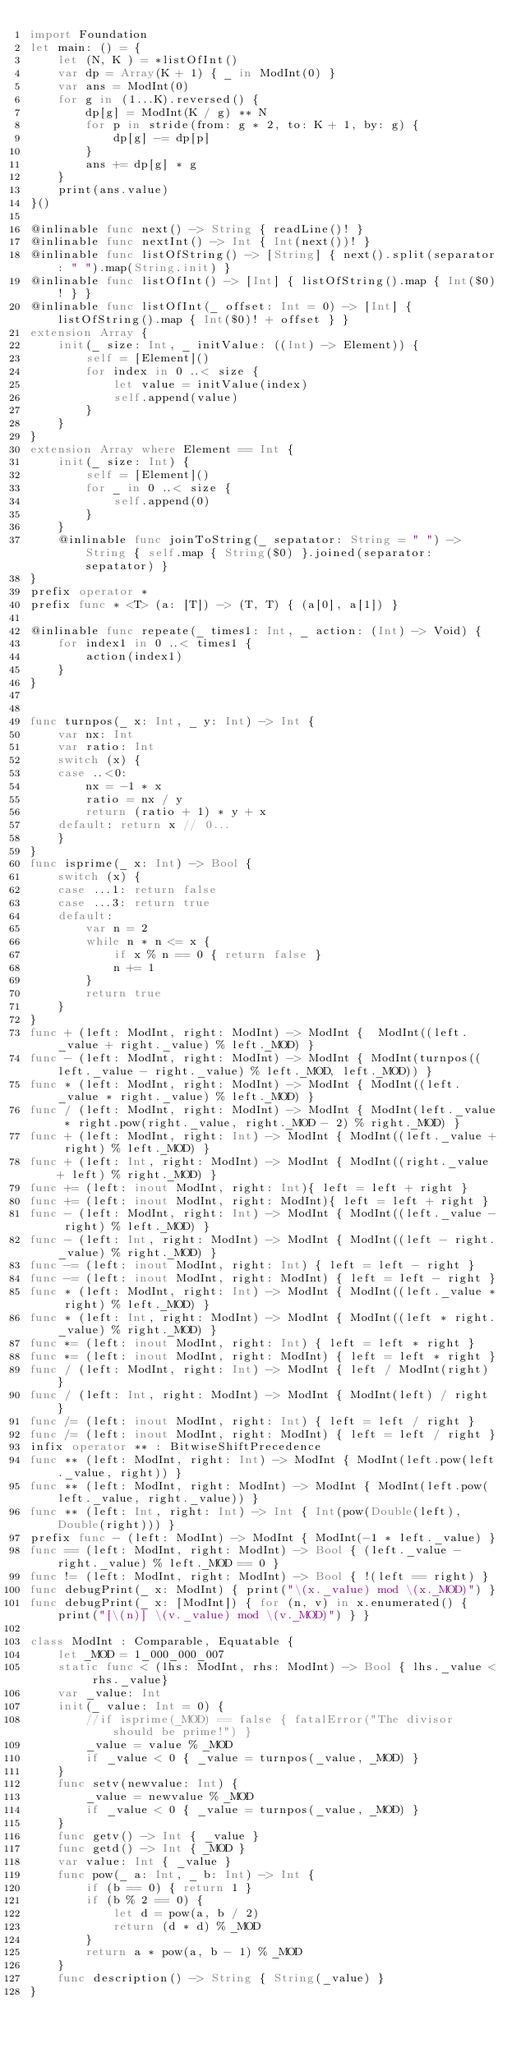Convert code to text. <code><loc_0><loc_0><loc_500><loc_500><_Swift_>import Foundation
let main: () = {
    let (N, K ) = *listOfInt()
    var dp = Array(K + 1) { _ in ModInt(0) }
    var ans = ModInt(0)
    for g in (1...K).reversed() {
        dp[g] = ModInt(K / g) ** N
        for p in stride(from: g * 2, to: K + 1, by: g) {
            dp[g] -= dp[p]
        }
        ans += dp[g] * g
    }
    print(ans.value)
}()

@inlinable func next() -> String { readLine()! }
@inlinable func nextInt() -> Int { Int(next())! }
@inlinable func listOfString() -> [String] { next().split(separator: " ").map(String.init) }
@inlinable func listOfInt() -> [Int] { listOfString().map { Int($0)! } }
@inlinable func listOfInt(_ offset: Int = 0) -> [Int] { listOfString().map { Int($0)! + offset } }
extension Array {
    init(_ size: Int, _ initValue: ((Int) -> Element)) {
        self = [Element]()
        for index in 0 ..< size {
            let value = initValue(index)
            self.append(value)
        }
    }
}
extension Array where Element == Int {
    init(_ size: Int) {
        self = [Element]()
        for _ in 0 ..< size {
            self.append(0)
        }
    }
    @inlinable func joinToString(_ sepatator: String = " ") -> String { self.map { String($0) }.joined(separator: sepatator) }
}
prefix operator *
prefix func * <T> (a: [T]) -> (T, T) { (a[0], a[1]) }

@inlinable func repeate(_ times1: Int, _ action: (Int) -> Void) {
    for index1 in 0 ..< times1 {
        action(index1)
    }
}


func turnpos(_ x: Int, _ y: Int) -> Int {
    var nx: Int
    var ratio: Int
    switch (x) {
    case ..<0:
        nx = -1 * x
        ratio = nx / y
        return (ratio + 1) * y + x
    default: return x // 0...
    }
}
func isprime(_ x: Int) -> Bool {
    switch (x) {
    case ...1: return false
    case ...3: return true
    default:
        var n = 2
        while n * n <= x {
            if x % n == 0 { return false }
            n += 1
        }
        return true
    }
}
func + (left: ModInt, right: ModInt) -> ModInt {  ModInt((left._value + right._value) % left._MOD) }
func - (left: ModInt, right: ModInt) -> ModInt { ModInt(turnpos((left._value - right._value) % left._MOD, left._MOD)) }
func * (left: ModInt, right: ModInt) -> ModInt { ModInt((left._value * right._value) % left._MOD) }
func / (left: ModInt, right: ModInt) -> ModInt { ModInt(left._value * right.pow(right._value, right._MOD - 2) % right._MOD) }
func + (left: ModInt, right: Int) -> ModInt { ModInt((left._value + right) % left._MOD) }
func + (left: Int, right: ModInt) -> ModInt { ModInt((right._value + left) % right._MOD) }
func += (left: inout ModInt, right: Int){ left = left + right }
func += (left: inout ModInt, right: ModInt){ left = left + right }
func - (left: ModInt, right: Int) -> ModInt { ModInt((left._value - right) % left._MOD) }
func - (left: Int, right: ModInt) -> ModInt { ModInt((left - right._value) % right._MOD) }
func -= (left: inout ModInt, right: Int) { left = left - right }
func -= (left: inout ModInt, right: ModInt) { left = left - right }
func * (left: ModInt, right: Int) -> ModInt { ModInt((left._value * right) % left._MOD) }
func * (left: Int, right: ModInt) -> ModInt { ModInt((left * right._value) % right._MOD) }
func *= (left: inout ModInt, right: Int) { left = left * right }
func *= (left: inout ModInt, right: ModInt) { left = left * right }
func / (left: ModInt, right: Int) -> ModInt { left / ModInt(right) }
func / (left: Int, right: ModInt) -> ModInt { ModInt(left) / right }
func /= (left: inout ModInt, right: Int) { left = left / right }
func /= (left: inout ModInt, right: ModInt) { left = left / right }
infix operator ** : BitwiseShiftPrecedence
func ** (left: ModInt, right: Int) -> ModInt { ModInt(left.pow(left._value, right)) }
func ** (left: ModInt, right: ModInt) -> ModInt { ModInt(left.pow(left._value, right._value)) }
func ** (left: Int, right: Int) -> Int { Int(pow(Double(left), Double(right))) }
prefix func - (left: ModInt) -> ModInt { ModInt(-1 * left._value) }
func == (left: ModInt, right: ModInt) -> Bool { (left._value - right._value) % left._MOD == 0 }
func != (left: ModInt, right: ModInt) -> Bool { !(left == right) }
func debugPrint(_ x: ModInt) { print("\(x._value) mod \(x._MOD)") }
func debugPrint(_ x: [ModInt]) { for (n, v) in x.enumerated() { print("[\(n)] \(v._value) mod \(v._MOD)") } }

class ModInt : Comparable, Equatable {
    let _MOD = 1_000_000_007
    static func < (lhs: ModInt, rhs: ModInt) -> Bool { lhs._value < rhs._value}
    var _value: Int
    init(_ value: Int = 0) {
        //if isprime(_MOD) == false { fatalError("The divisor should be prime!") }
        _value = value % _MOD
        if _value < 0 { _value = turnpos(_value, _MOD) }
    }
    func setv(newvalue: Int) {
        _value = newvalue % _MOD
        if _value < 0 { _value = turnpos(_value, _MOD) }
    }
    func getv() -> Int { _value }
    func getd() -> Int { _MOD }
    var value: Int { _value }
    func pow(_ a: Int, _ b: Int) -> Int {
        if (b == 0) { return 1 }
        if (b % 2 == 0) {
            let d = pow(a, b / 2)
            return (d * d) % _MOD
        }
        return a * pow(a, b - 1) % _MOD
    }
    func description() -> String { String(_value) }
}
</code> 